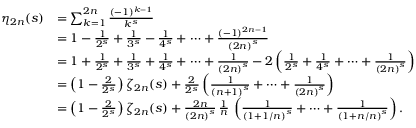<formula> <loc_0><loc_0><loc_500><loc_500>{ \begin{array} { r l } { \eta _ { 2 n } ( s ) } & { = \sum _ { k = 1 } ^ { 2 n } { \frac { ( - 1 ) ^ { k - 1 } } { k ^ { s } } } } \\ & { = 1 - { \frac { 1 } { 2 ^ { s } } } + { \frac { 1 } { 3 ^ { s } } } - { \frac { 1 } { 4 ^ { s } } } + \dots + { \frac { ( - 1 ) ^ { 2 n - 1 } } { { ( 2 n ) } ^ { s } } } } \\ & { = 1 + { \frac { 1 } { 2 ^ { s } } } + { \frac { 1 } { 3 ^ { s } } } + { \frac { 1 } { 4 ^ { s } } } + \dots + { \frac { 1 } { { ( 2 n ) } ^ { s } } } - 2 \left ( { \frac { 1 } { 2 ^ { s } } } + { \frac { 1 } { 4 ^ { s } } } + \dots + { \frac { 1 } { { ( 2 n ) } ^ { s } } } \right ) } \\ & { = \left ( 1 - { \frac { 2 } { 2 ^ { s } } } \right ) \zeta _ { 2 n } ( s ) + { \frac { 2 } { 2 ^ { s } } } \left ( { \frac { 1 } { { ( n + 1 ) } ^ { s } } } + \dots + { \frac { 1 } { { ( 2 n ) } ^ { s } } } \right ) } \\ & { = \left ( 1 - { \frac { 2 } { 2 ^ { s } } } \right ) \zeta _ { 2 n } ( s ) + { \frac { 2 n } { { ( 2 n ) } ^ { s } } } \, { \frac { 1 } { n } } \, \left ( { \frac { 1 } { { ( 1 + 1 / n ) } ^ { s } } } + \dots + { \frac { 1 } { { ( 1 + n / n ) } ^ { s } } } \right ) . } \end{array} }</formula> 